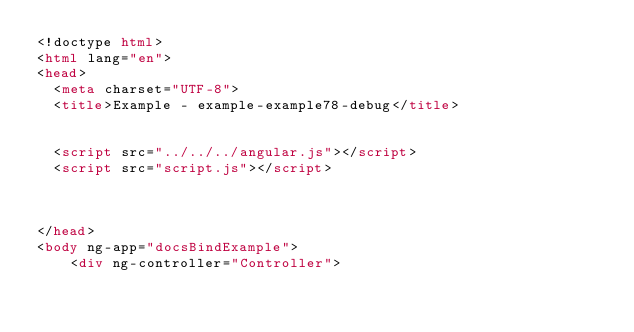<code> <loc_0><loc_0><loc_500><loc_500><_HTML_><!doctype html>
<html lang="en">
<head>
  <meta charset="UTF-8">
  <title>Example - example-example78-debug</title>
  

  <script src="../../../angular.js"></script>
  <script src="script.js"></script>
  

  
</head>
<body ng-app="docsBindExample">
    <div ng-controller="Controller"></code> 